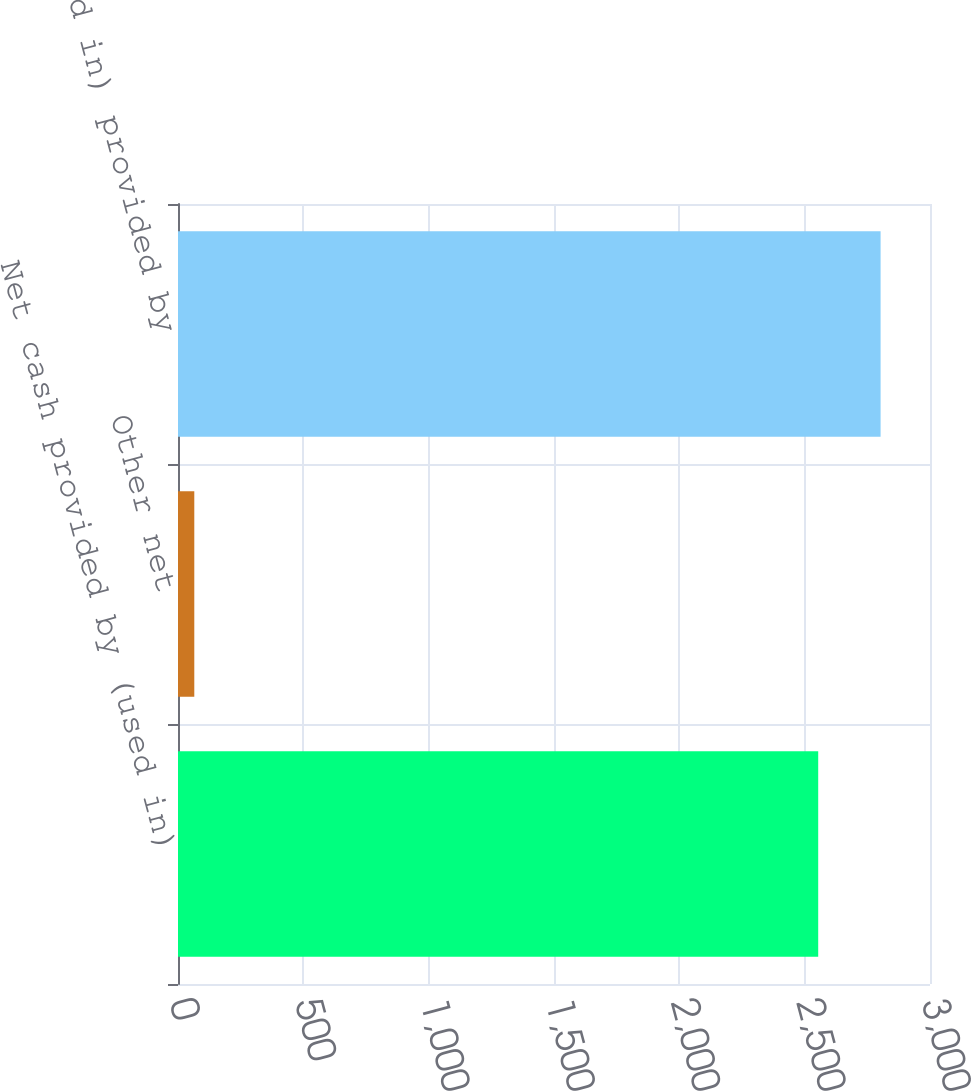<chart> <loc_0><loc_0><loc_500><loc_500><bar_chart><fcel>Net cash provided by (used in)<fcel>Other net<fcel>Net cash (used in) provided by<nl><fcel>2554<fcel>65<fcel>2802.9<nl></chart> 